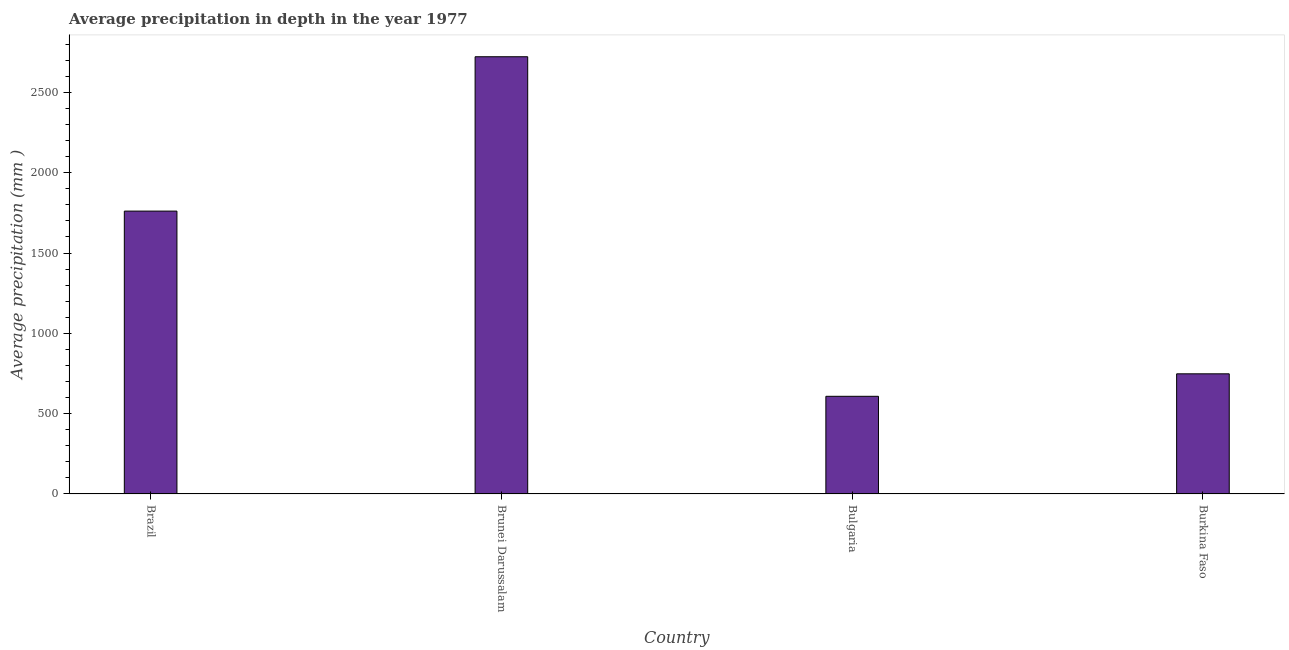Does the graph contain any zero values?
Provide a succinct answer. No. Does the graph contain grids?
Your response must be concise. No. What is the title of the graph?
Ensure brevity in your answer.  Average precipitation in depth in the year 1977. What is the label or title of the X-axis?
Give a very brief answer. Country. What is the label or title of the Y-axis?
Offer a terse response. Average precipitation (mm ). What is the average precipitation in depth in Brazil?
Provide a succinct answer. 1761. Across all countries, what is the maximum average precipitation in depth?
Your answer should be very brief. 2722. Across all countries, what is the minimum average precipitation in depth?
Your answer should be very brief. 608. In which country was the average precipitation in depth maximum?
Your answer should be very brief. Brunei Darussalam. In which country was the average precipitation in depth minimum?
Your response must be concise. Bulgaria. What is the sum of the average precipitation in depth?
Your response must be concise. 5839. What is the difference between the average precipitation in depth in Brunei Darussalam and Burkina Faso?
Offer a very short reply. 1974. What is the average average precipitation in depth per country?
Your answer should be compact. 1459. What is the median average precipitation in depth?
Your answer should be compact. 1254.5. In how many countries, is the average precipitation in depth greater than 800 mm?
Provide a succinct answer. 2. What is the ratio of the average precipitation in depth in Brazil to that in Brunei Darussalam?
Your answer should be compact. 0.65. Is the difference between the average precipitation in depth in Bulgaria and Burkina Faso greater than the difference between any two countries?
Keep it short and to the point. No. What is the difference between the highest and the second highest average precipitation in depth?
Provide a succinct answer. 961. What is the difference between the highest and the lowest average precipitation in depth?
Provide a succinct answer. 2114. In how many countries, is the average precipitation in depth greater than the average average precipitation in depth taken over all countries?
Offer a terse response. 2. How many bars are there?
Provide a short and direct response. 4. Are all the bars in the graph horizontal?
Make the answer very short. No. How many countries are there in the graph?
Your answer should be very brief. 4. What is the Average precipitation (mm ) in Brazil?
Your response must be concise. 1761. What is the Average precipitation (mm ) in Brunei Darussalam?
Your answer should be compact. 2722. What is the Average precipitation (mm ) in Bulgaria?
Give a very brief answer. 608. What is the Average precipitation (mm ) of Burkina Faso?
Ensure brevity in your answer.  748. What is the difference between the Average precipitation (mm ) in Brazil and Brunei Darussalam?
Offer a terse response. -961. What is the difference between the Average precipitation (mm ) in Brazil and Bulgaria?
Your response must be concise. 1153. What is the difference between the Average precipitation (mm ) in Brazil and Burkina Faso?
Provide a succinct answer. 1013. What is the difference between the Average precipitation (mm ) in Brunei Darussalam and Bulgaria?
Your response must be concise. 2114. What is the difference between the Average precipitation (mm ) in Brunei Darussalam and Burkina Faso?
Provide a succinct answer. 1974. What is the difference between the Average precipitation (mm ) in Bulgaria and Burkina Faso?
Provide a short and direct response. -140. What is the ratio of the Average precipitation (mm ) in Brazil to that in Brunei Darussalam?
Provide a short and direct response. 0.65. What is the ratio of the Average precipitation (mm ) in Brazil to that in Bulgaria?
Ensure brevity in your answer.  2.9. What is the ratio of the Average precipitation (mm ) in Brazil to that in Burkina Faso?
Offer a terse response. 2.35. What is the ratio of the Average precipitation (mm ) in Brunei Darussalam to that in Bulgaria?
Your answer should be compact. 4.48. What is the ratio of the Average precipitation (mm ) in Brunei Darussalam to that in Burkina Faso?
Ensure brevity in your answer.  3.64. What is the ratio of the Average precipitation (mm ) in Bulgaria to that in Burkina Faso?
Provide a short and direct response. 0.81. 